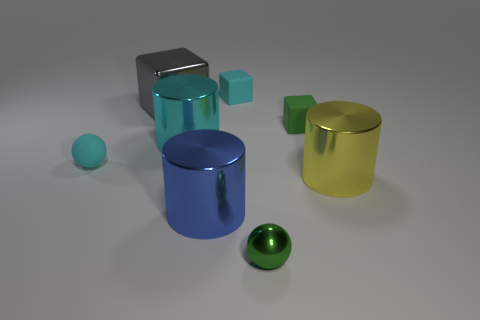There is a big cube; is it the same color as the small rubber object left of the big cyan shiny cylinder?
Your answer should be compact. No. Is there a small object that has the same color as the shiny block?
Keep it short and to the point. No. How many green things are balls or small metallic spheres?
Offer a very short reply. 1. What number of metallic cubes are the same size as the blue cylinder?
Your response must be concise. 1. What shape is the big metal object that is the same color as the tiny matte sphere?
Give a very brief answer. Cylinder. How many objects are big blue metallic things or small blocks behind the gray block?
Make the answer very short. 2. Do the rubber block that is to the right of the green sphere and the rubber cube to the left of the small green metallic sphere have the same size?
Give a very brief answer. Yes. What number of blue things are the same shape as the big cyan object?
Your response must be concise. 1. What is the shape of the blue thing that is the same material as the yellow cylinder?
Your answer should be very brief. Cylinder. What material is the cyan thing in front of the big metallic cylinder behind the tiny cyan object in front of the cyan shiny object made of?
Provide a succinct answer. Rubber. 